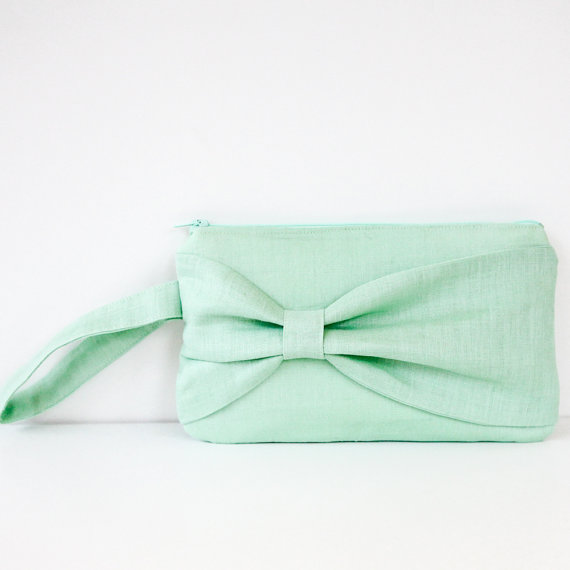How might this clutch be customized to reflect personal style or preferences? This clutch purse can be customized in several ways to reflect personal style or preferences. Adding monogrammed initials or a favorite quote on the inside lining can give it a unique, personalized touch. For those who prefer a bit of sparkle, tiny sequins, beads, or crystal embellishments can be hand-sewn onto the bow or the front of the purse. The wrist strap can be replaced with a chain or leather strap in a contrasting color for added style. Additionally, the purse could be dyed to a custom shade, or the bow could be changed to a different design or material to better suit the owner’s aesthetic. Such customizations can turn this elegantly simple clutch into a one-of-a-kind fashion statement. 